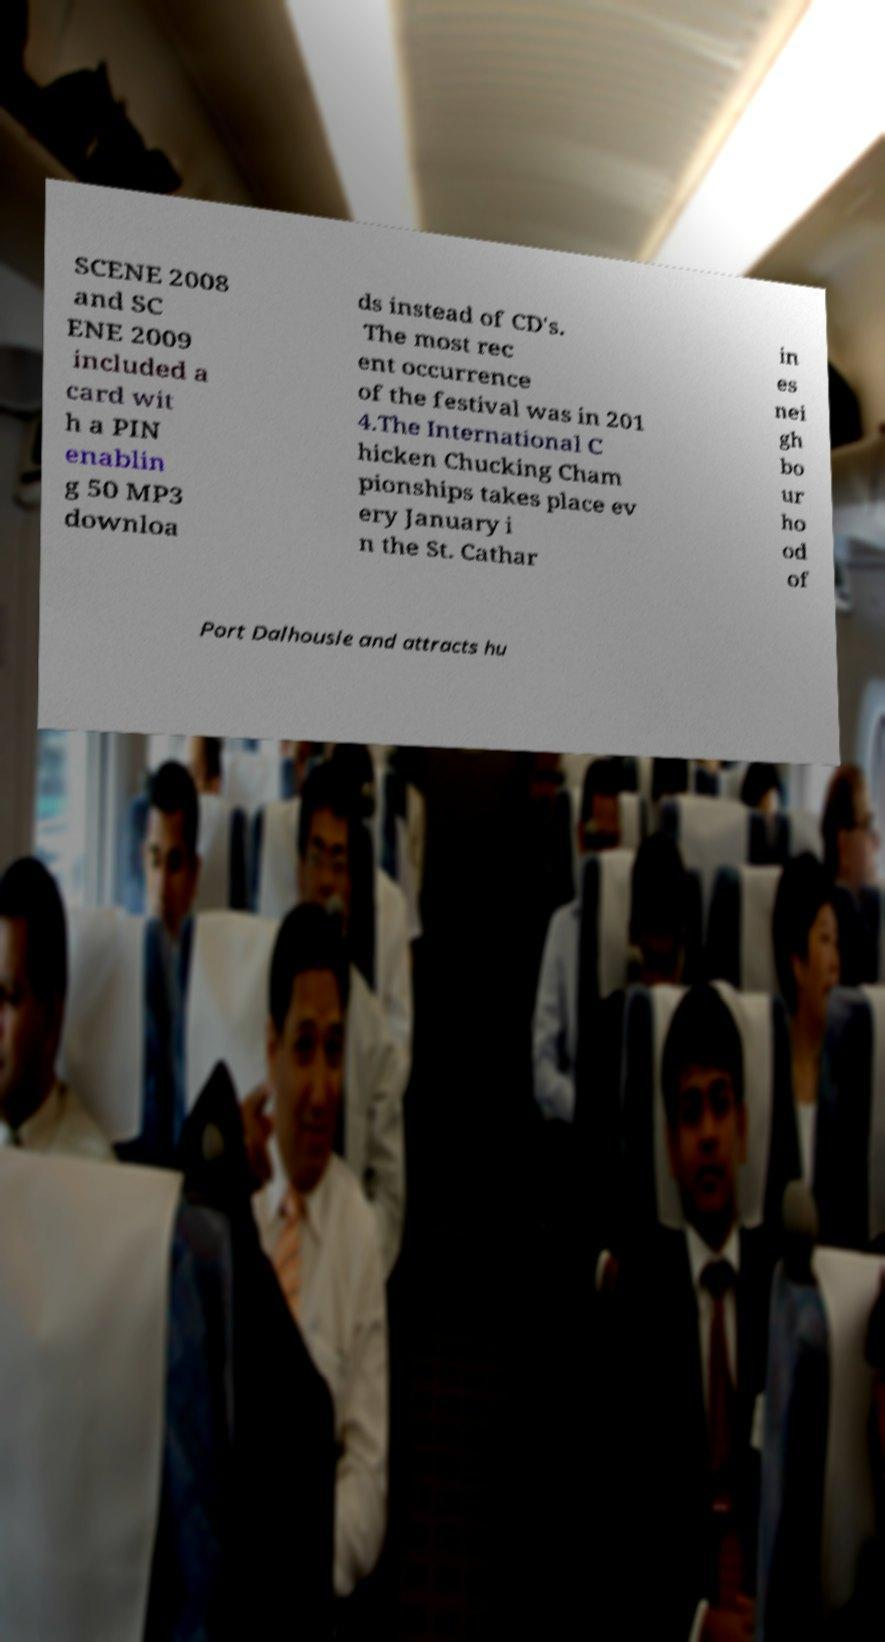Can you accurately transcribe the text from the provided image for me? SCENE 2008 and SC ENE 2009 included a card wit h a PIN enablin g 50 MP3 downloa ds instead of CD's. The most rec ent occurrence of the festival was in 201 4.The International C hicken Chucking Cham pionships takes place ev ery January i n the St. Cathar in es nei gh bo ur ho od of Port Dalhousie and attracts hu 